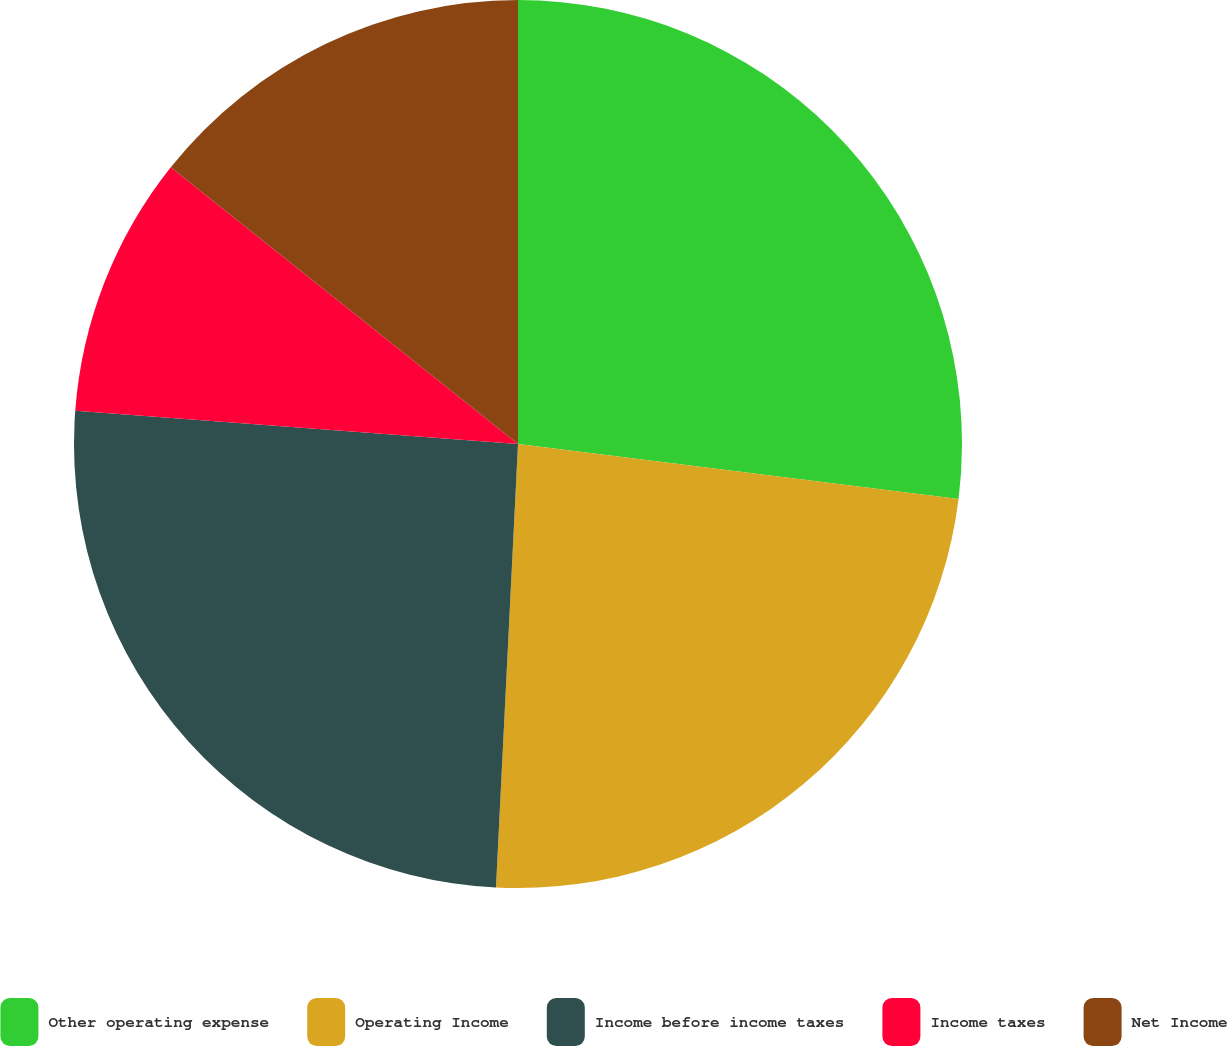Convert chart to OTSL. <chart><loc_0><loc_0><loc_500><loc_500><pie_chart><fcel>Other operating expense<fcel>Operating Income<fcel>Income before income taxes<fcel>Income taxes<fcel>Net Income<nl><fcel>26.98%<fcel>23.81%<fcel>25.4%<fcel>9.52%<fcel>14.29%<nl></chart> 